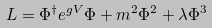Convert formula to latex. <formula><loc_0><loc_0><loc_500><loc_500>L = \Phi ^ { \dagger } e ^ { g V } \Phi + m ^ { 2 } \Phi ^ { 2 } + \lambda \Phi ^ { 3 }</formula> 